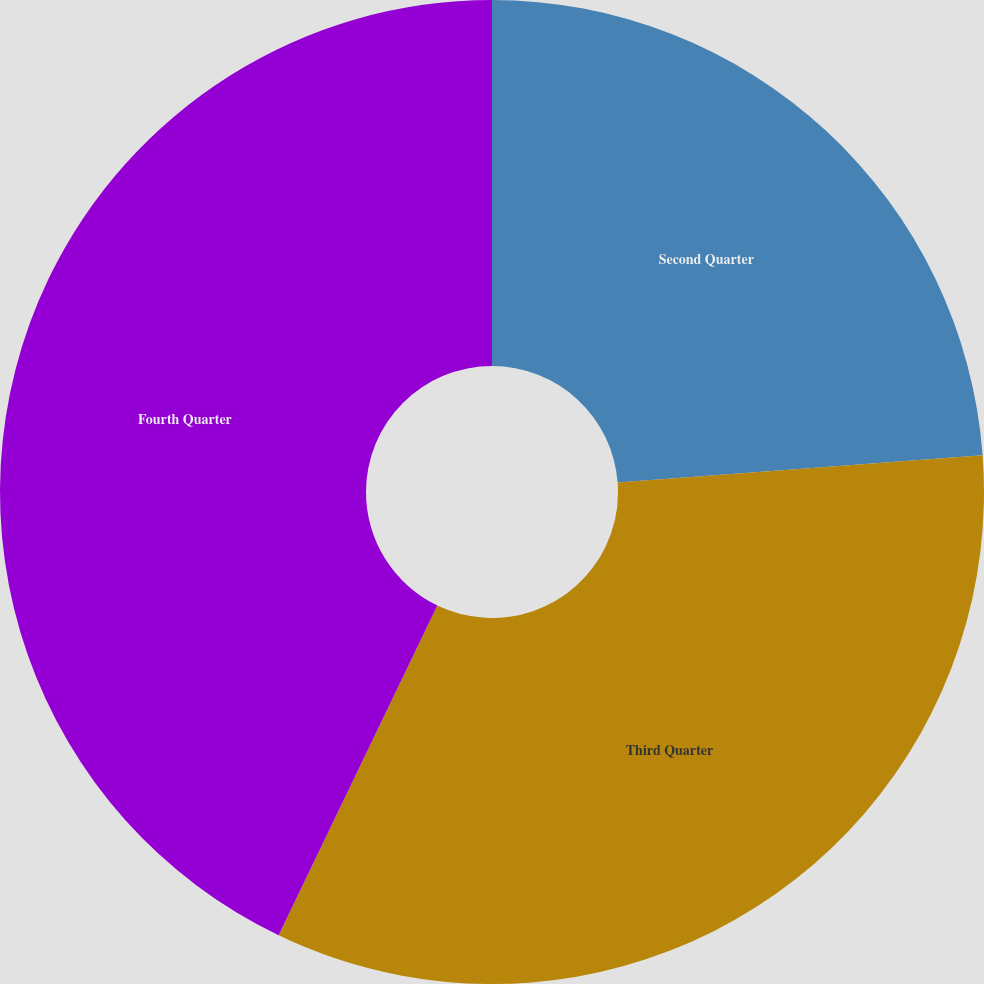Convert chart. <chart><loc_0><loc_0><loc_500><loc_500><pie_chart><fcel>Second Quarter<fcel>Third Quarter<fcel>Fourth Quarter<nl><fcel>23.81%<fcel>33.33%<fcel>42.86%<nl></chart> 